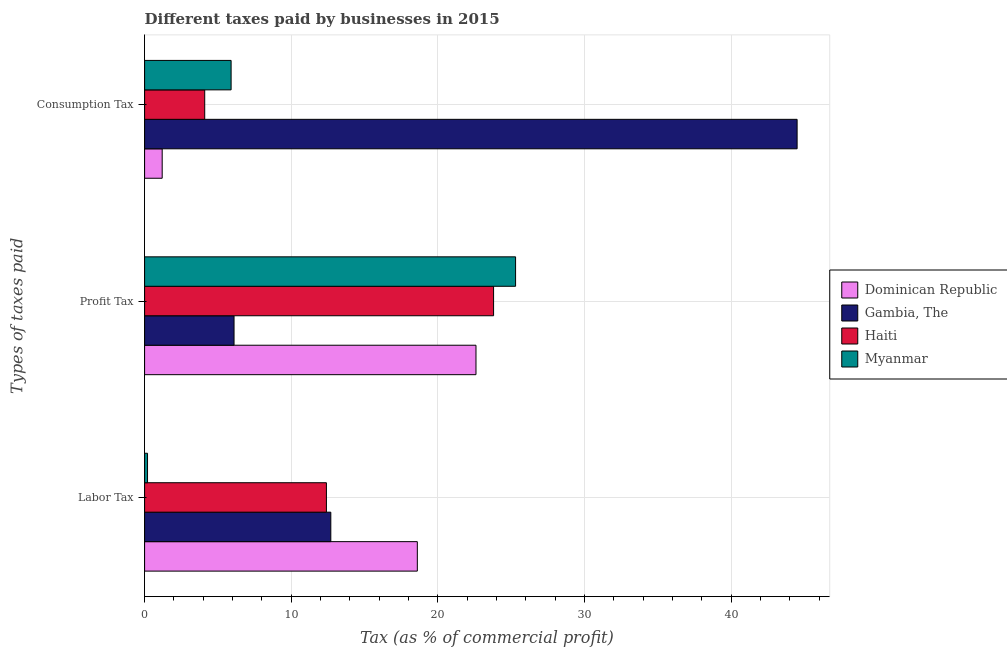How many different coloured bars are there?
Offer a terse response. 4. Are the number of bars per tick equal to the number of legend labels?
Your answer should be very brief. Yes. How many bars are there on the 1st tick from the top?
Offer a very short reply. 4. What is the label of the 2nd group of bars from the top?
Offer a terse response. Profit Tax. What is the percentage of consumption tax in Gambia, The?
Provide a succinct answer. 44.5. Across all countries, what is the maximum percentage of consumption tax?
Provide a succinct answer. 44.5. In which country was the percentage of labor tax maximum?
Provide a succinct answer. Dominican Republic. In which country was the percentage of labor tax minimum?
Provide a succinct answer. Myanmar. What is the total percentage of consumption tax in the graph?
Keep it short and to the point. 55.7. What is the average percentage of profit tax per country?
Your answer should be very brief. 19.45. What is the difference between the percentage of consumption tax and percentage of labor tax in Dominican Republic?
Your response must be concise. -17.4. In how many countries, is the percentage of labor tax greater than 26 %?
Ensure brevity in your answer.  0. Is the percentage of profit tax in Gambia, The less than that in Myanmar?
Keep it short and to the point. Yes. Is the difference between the percentage of consumption tax in Haiti and Dominican Republic greater than the difference between the percentage of profit tax in Haiti and Dominican Republic?
Give a very brief answer. Yes. What is the difference between the highest and the second highest percentage of profit tax?
Your response must be concise. 1.5. What is the difference between the highest and the lowest percentage of profit tax?
Give a very brief answer. 19.2. Is the sum of the percentage of labor tax in Gambia, The and Myanmar greater than the maximum percentage of profit tax across all countries?
Make the answer very short. No. What does the 4th bar from the top in Consumption Tax represents?
Your answer should be compact. Dominican Republic. What does the 1st bar from the bottom in Labor Tax represents?
Your response must be concise. Dominican Republic. Is it the case that in every country, the sum of the percentage of labor tax and percentage of profit tax is greater than the percentage of consumption tax?
Offer a terse response. No. How many bars are there?
Your answer should be very brief. 12. Are all the bars in the graph horizontal?
Give a very brief answer. Yes. How many legend labels are there?
Your answer should be compact. 4. How are the legend labels stacked?
Your response must be concise. Vertical. What is the title of the graph?
Give a very brief answer. Different taxes paid by businesses in 2015. Does "Middle income" appear as one of the legend labels in the graph?
Offer a very short reply. No. What is the label or title of the X-axis?
Ensure brevity in your answer.  Tax (as % of commercial profit). What is the label or title of the Y-axis?
Your response must be concise. Types of taxes paid. What is the Tax (as % of commercial profit) in Dominican Republic in Labor Tax?
Give a very brief answer. 18.6. What is the Tax (as % of commercial profit) of Myanmar in Labor Tax?
Your response must be concise. 0.2. What is the Tax (as % of commercial profit) of Dominican Republic in Profit Tax?
Provide a succinct answer. 22.6. What is the Tax (as % of commercial profit) in Gambia, The in Profit Tax?
Provide a succinct answer. 6.1. What is the Tax (as % of commercial profit) of Haiti in Profit Tax?
Your answer should be very brief. 23.8. What is the Tax (as % of commercial profit) in Myanmar in Profit Tax?
Give a very brief answer. 25.3. What is the Tax (as % of commercial profit) of Gambia, The in Consumption Tax?
Keep it short and to the point. 44.5. What is the Tax (as % of commercial profit) in Haiti in Consumption Tax?
Provide a succinct answer. 4.1. Across all Types of taxes paid, what is the maximum Tax (as % of commercial profit) in Dominican Republic?
Offer a terse response. 22.6. Across all Types of taxes paid, what is the maximum Tax (as % of commercial profit) in Gambia, The?
Offer a terse response. 44.5. Across all Types of taxes paid, what is the maximum Tax (as % of commercial profit) in Haiti?
Your answer should be compact. 23.8. Across all Types of taxes paid, what is the maximum Tax (as % of commercial profit) in Myanmar?
Keep it short and to the point. 25.3. Across all Types of taxes paid, what is the minimum Tax (as % of commercial profit) in Dominican Republic?
Offer a terse response. 1.2. Across all Types of taxes paid, what is the minimum Tax (as % of commercial profit) in Haiti?
Ensure brevity in your answer.  4.1. Across all Types of taxes paid, what is the minimum Tax (as % of commercial profit) of Myanmar?
Offer a terse response. 0.2. What is the total Tax (as % of commercial profit) of Dominican Republic in the graph?
Your response must be concise. 42.4. What is the total Tax (as % of commercial profit) of Gambia, The in the graph?
Make the answer very short. 63.3. What is the total Tax (as % of commercial profit) in Haiti in the graph?
Make the answer very short. 40.3. What is the total Tax (as % of commercial profit) in Myanmar in the graph?
Your response must be concise. 31.4. What is the difference between the Tax (as % of commercial profit) in Gambia, The in Labor Tax and that in Profit Tax?
Offer a terse response. 6.6. What is the difference between the Tax (as % of commercial profit) in Myanmar in Labor Tax and that in Profit Tax?
Give a very brief answer. -25.1. What is the difference between the Tax (as % of commercial profit) in Dominican Republic in Labor Tax and that in Consumption Tax?
Give a very brief answer. 17.4. What is the difference between the Tax (as % of commercial profit) of Gambia, The in Labor Tax and that in Consumption Tax?
Your answer should be compact. -31.8. What is the difference between the Tax (as % of commercial profit) in Haiti in Labor Tax and that in Consumption Tax?
Offer a terse response. 8.3. What is the difference between the Tax (as % of commercial profit) of Myanmar in Labor Tax and that in Consumption Tax?
Make the answer very short. -5.7. What is the difference between the Tax (as % of commercial profit) in Dominican Republic in Profit Tax and that in Consumption Tax?
Offer a terse response. 21.4. What is the difference between the Tax (as % of commercial profit) in Gambia, The in Profit Tax and that in Consumption Tax?
Offer a terse response. -38.4. What is the difference between the Tax (as % of commercial profit) in Dominican Republic in Labor Tax and the Tax (as % of commercial profit) in Myanmar in Profit Tax?
Keep it short and to the point. -6.7. What is the difference between the Tax (as % of commercial profit) in Gambia, The in Labor Tax and the Tax (as % of commercial profit) in Haiti in Profit Tax?
Your answer should be compact. -11.1. What is the difference between the Tax (as % of commercial profit) in Dominican Republic in Labor Tax and the Tax (as % of commercial profit) in Gambia, The in Consumption Tax?
Give a very brief answer. -25.9. What is the difference between the Tax (as % of commercial profit) in Dominican Republic in Labor Tax and the Tax (as % of commercial profit) in Haiti in Consumption Tax?
Offer a very short reply. 14.5. What is the difference between the Tax (as % of commercial profit) in Dominican Republic in Labor Tax and the Tax (as % of commercial profit) in Myanmar in Consumption Tax?
Your response must be concise. 12.7. What is the difference between the Tax (as % of commercial profit) of Gambia, The in Labor Tax and the Tax (as % of commercial profit) of Myanmar in Consumption Tax?
Provide a short and direct response. 6.8. What is the difference between the Tax (as % of commercial profit) in Dominican Republic in Profit Tax and the Tax (as % of commercial profit) in Gambia, The in Consumption Tax?
Offer a terse response. -21.9. What is the difference between the Tax (as % of commercial profit) of Dominican Republic in Profit Tax and the Tax (as % of commercial profit) of Haiti in Consumption Tax?
Your response must be concise. 18.5. What is the difference between the Tax (as % of commercial profit) in Dominican Republic in Profit Tax and the Tax (as % of commercial profit) in Myanmar in Consumption Tax?
Offer a terse response. 16.7. What is the difference between the Tax (as % of commercial profit) of Gambia, The in Profit Tax and the Tax (as % of commercial profit) of Haiti in Consumption Tax?
Offer a very short reply. 2. What is the difference between the Tax (as % of commercial profit) of Gambia, The in Profit Tax and the Tax (as % of commercial profit) of Myanmar in Consumption Tax?
Ensure brevity in your answer.  0.2. What is the average Tax (as % of commercial profit) of Dominican Republic per Types of taxes paid?
Provide a short and direct response. 14.13. What is the average Tax (as % of commercial profit) of Gambia, The per Types of taxes paid?
Keep it short and to the point. 21.1. What is the average Tax (as % of commercial profit) of Haiti per Types of taxes paid?
Your answer should be very brief. 13.43. What is the average Tax (as % of commercial profit) in Myanmar per Types of taxes paid?
Your answer should be very brief. 10.47. What is the difference between the Tax (as % of commercial profit) of Dominican Republic and Tax (as % of commercial profit) of Gambia, The in Labor Tax?
Provide a short and direct response. 5.9. What is the difference between the Tax (as % of commercial profit) in Dominican Republic and Tax (as % of commercial profit) in Myanmar in Labor Tax?
Provide a short and direct response. 18.4. What is the difference between the Tax (as % of commercial profit) in Gambia, The and Tax (as % of commercial profit) in Haiti in Labor Tax?
Provide a short and direct response. 0.3. What is the difference between the Tax (as % of commercial profit) in Gambia, The and Tax (as % of commercial profit) in Myanmar in Labor Tax?
Provide a short and direct response. 12.5. What is the difference between the Tax (as % of commercial profit) in Dominican Republic and Tax (as % of commercial profit) in Gambia, The in Profit Tax?
Offer a terse response. 16.5. What is the difference between the Tax (as % of commercial profit) in Gambia, The and Tax (as % of commercial profit) in Haiti in Profit Tax?
Your response must be concise. -17.7. What is the difference between the Tax (as % of commercial profit) of Gambia, The and Tax (as % of commercial profit) of Myanmar in Profit Tax?
Provide a succinct answer. -19.2. What is the difference between the Tax (as % of commercial profit) of Dominican Republic and Tax (as % of commercial profit) of Gambia, The in Consumption Tax?
Keep it short and to the point. -43.3. What is the difference between the Tax (as % of commercial profit) in Dominican Republic and Tax (as % of commercial profit) in Haiti in Consumption Tax?
Offer a very short reply. -2.9. What is the difference between the Tax (as % of commercial profit) in Gambia, The and Tax (as % of commercial profit) in Haiti in Consumption Tax?
Ensure brevity in your answer.  40.4. What is the difference between the Tax (as % of commercial profit) of Gambia, The and Tax (as % of commercial profit) of Myanmar in Consumption Tax?
Make the answer very short. 38.6. What is the difference between the Tax (as % of commercial profit) of Haiti and Tax (as % of commercial profit) of Myanmar in Consumption Tax?
Provide a short and direct response. -1.8. What is the ratio of the Tax (as % of commercial profit) in Dominican Republic in Labor Tax to that in Profit Tax?
Provide a short and direct response. 0.82. What is the ratio of the Tax (as % of commercial profit) of Gambia, The in Labor Tax to that in Profit Tax?
Offer a very short reply. 2.08. What is the ratio of the Tax (as % of commercial profit) of Haiti in Labor Tax to that in Profit Tax?
Your answer should be very brief. 0.52. What is the ratio of the Tax (as % of commercial profit) of Myanmar in Labor Tax to that in Profit Tax?
Keep it short and to the point. 0.01. What is the ratio of the Tax (as % of commercial profit) in Dominican Republic in Labor Tax to that in Consumption Tax?
Keep it short and to the point. 15.5. What is the ratio of the Tax (as % of commercial profit) in Gambia, The in Labor Tax to that in Consumption Tax?
Provide a short and direct response. 0.29. What is the ratio of the Tax (as % of commercial profit) in Haiti in Labor Tax to that in Consumption Tax?
Ensure brevity in your answer.  3.02. What is the ratio of the Tax (as % of commercial profit) in Myanmar in Labor Tax to that in Consumption Tax?
Make the answer very short. 0.03. What is the ratio of the Tax (as % of commercial profit) of Dominican Republic in Profit Tax to that in Consumption Tax?
Your response must be concise. 18.83. What is the ratio of the Tax (as % of commercial profit) of Gambia, The in Profit Tax to that in Consumption Tax?
Keep it short and to the point. 0.14. What is the ratio of the Tax (as % of commercial profit) of Haiti in Profit Tax to that in Consumption Tax?
Ensure brevity in your answer.  5.8. What is the ratio of the Tax (as % of commercial profit) in Myanmar in Profit Tax to that in Consumption Tax?
Provide a succinct answer. 4.29. What is the difference between the highest and the second highest Tax (as % of commercial profit) of Gambia, The?
Offer a terse response. 31.8. What is the difference between the highest and the second highest Tax (as % of commercial profit) of Haiti?
Keep it short and to the point. 11.4. What is the difference between the highest and the lowest Tax (as % of commercial profit) in Dominican Republic?
Keep it short and to the point. 21.4. What is the difference between the highest and the lowest Tax (as % of commercial profit) of Gambia, The?
Your answer should be compact. 38.4. What is the difference between the highest and the lowest Tax (as % of commercial profit) of Haiti?
Provide a succinct answer. 19.7. What is the difference between the highest and the lowest Tax (as % of commercial profit) of Myanmar?
Your answer should be very brief. 25.1. 